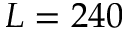<formula> <loc_0><loc_0><loc_500><loc_500>L = 2 4 0</formula> 